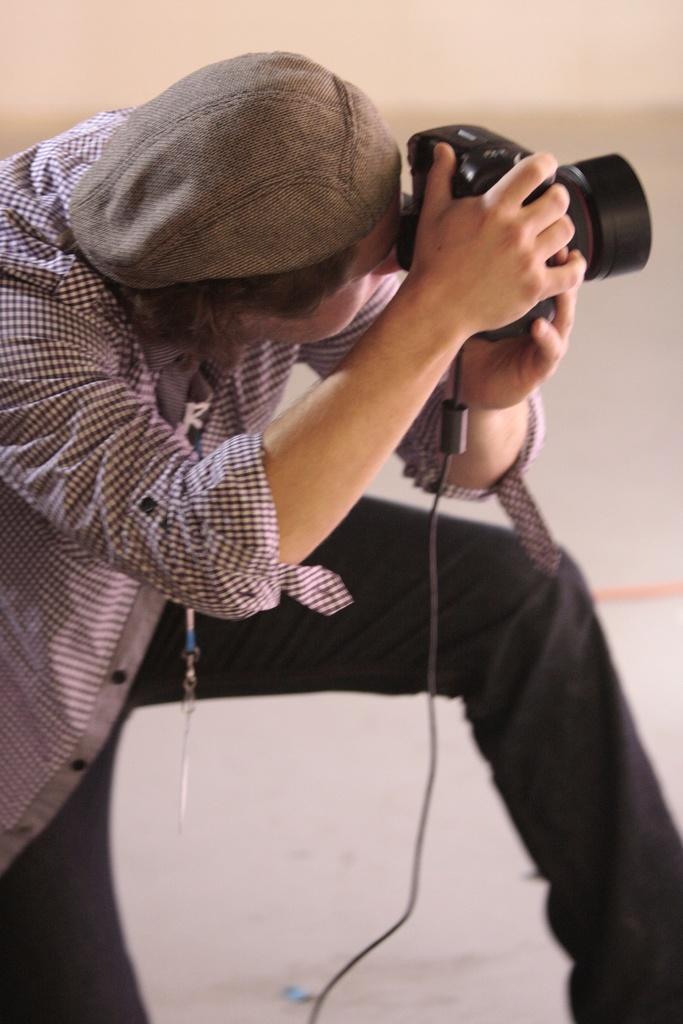Describe this image in one or two sentences. This image is taken indoors. In the background there is a wall. In the middle of the image a man is sitting on his knees and he is holding a camera in his hands and clicking pictures. 